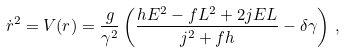Convert formula to latex. <formula><loc_0><loc_0><loc_500><loc_500>\dot { r } ^ { 2 } = V ( r ) = \frac { g } { \gamma ^ { 2 } } \left ( \frac { h E ^ { 2 } - f L ^ { 2 } + 2 j E L } { j ^ { 2 } + f h } - \delta \gamma \right ) \, ,</formula> 